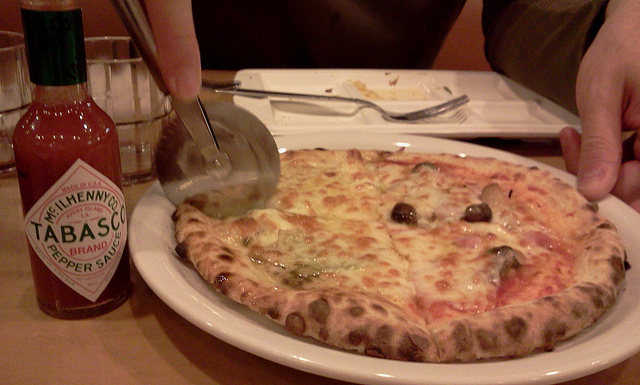Extract all visible text content from this image. TABASCO BRAND SAUCE PEPPER Mc. ILHENNY CO 